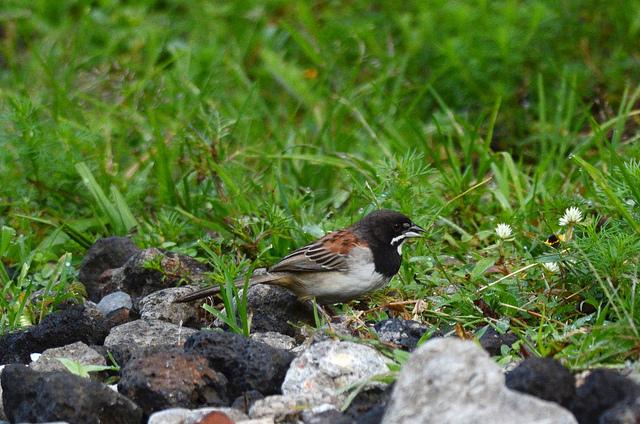How many birds?
Keep it brief. 1. What color are the majority of the rocks?
Give a very brief answer. Black. Do you see an insect in the picture?
Be succinct. No. 